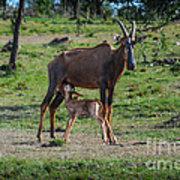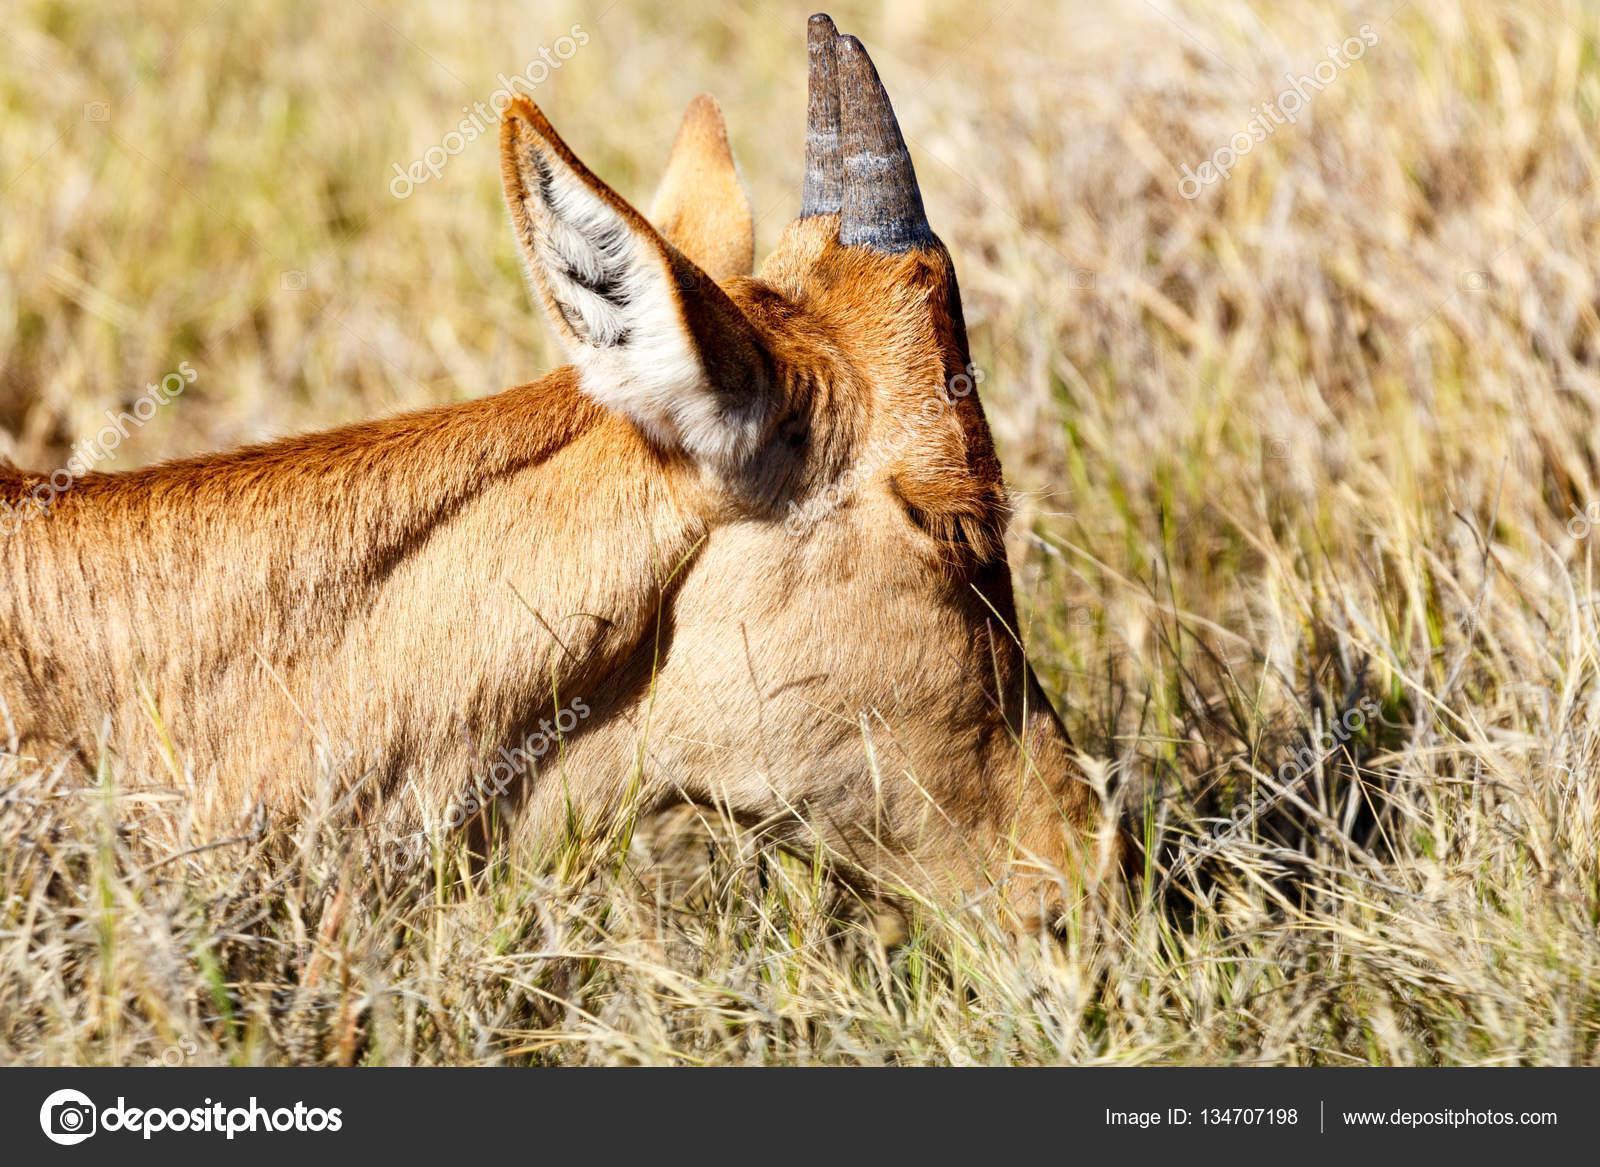The first image is the image on the left, the second image is the image on the right. For the images shown, is this caption "There are exactly two animals standing." true? Answer yes or no. Yes. The first image is the image on the left, the second image is the image on the right. Given the left and right images, does the statement "Only two antelopes are visible in the left image." hold true? Answer yes or no. Yes. 